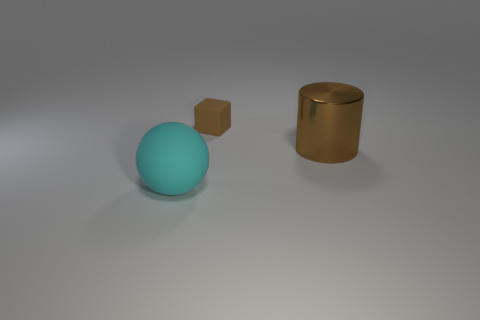Is there any other thing that has the same material as the brown cylinder?
Provide a succinct answer. No. What number of metal cylinders are on the left side of the rubber thing that is behind the cylinder?
Give a very brief answer. 0. How many things are objects that are behind the big ball or things that are in front of the tiny rubber thing?
Provide a succinct answer. 3. How many things are things that are to the right of the big cyan matte sphere or big cyan rubber balls?
Make the answer very short. 3. What shape is the thing that is made of the same material as the ball?
Offer a terse response. Cube. What number of cyan objects have the same shape as the brown matte thing?
Your response must be concise. 0. What material is the big brown thing?
Your answer should be very brief. Metal. There is a big matte thing; does it have the same color as the rubber thing that is behind the cylinder?
Give a very brief answer. No. How many spheres are cyan things or red rubber objects?
Your answer should be very brief. 1. There is a thing that is behind the cylinder; what is its color?
Offer a terse response. Brown. 